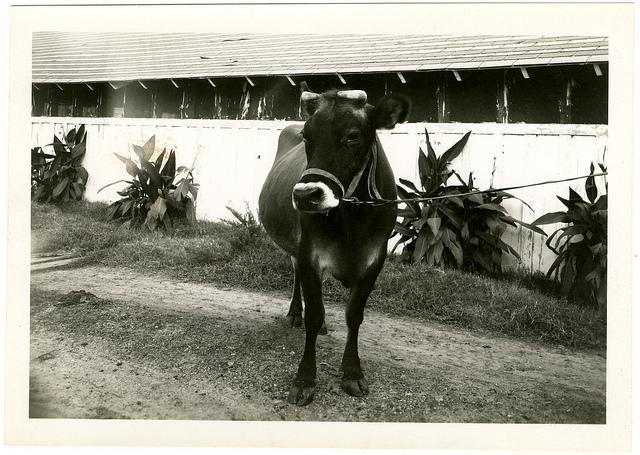Is the photo colorful?
Quick response, please. No. Is the cow tied up?
Keep it brief. Yes. Is the road paved?
Short answer required. No. 